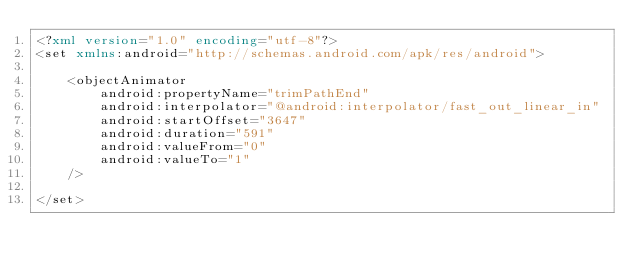<code> <loc_0><loc_0><loc_500><loc_500><_XML_><?xml version="1.0" encoding="utf-8"?>
<set xmlns:android="http://schemas.android.com/apk/res/android">

    <objectAnimator
        android:propertyName="trimPathEnd"
        android:interpolator="@android:interpolator/fast_out_linear_in"
        android:startOffset="3647"
        android:duration="591"
        android:valueFrom="0"
        android:valueTo="1"
    />

</set></code> 